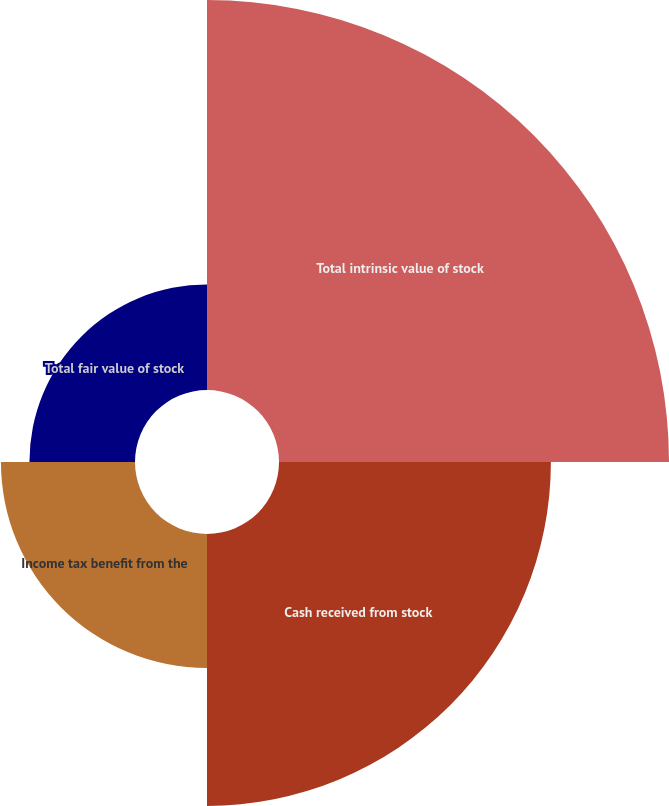<chart> <loc_0><loc_0><loc_500><loc_500><pie_chart><fcel>Total intrinsic value of stock<fcel>Cash received from stock<fcel>Income tax benefit from the<fcel>Total fair value of stock<nl><fcel>43.26%<fcel>30.16%<fcel>14.87%<fcel>11.71%<nl></chart> 